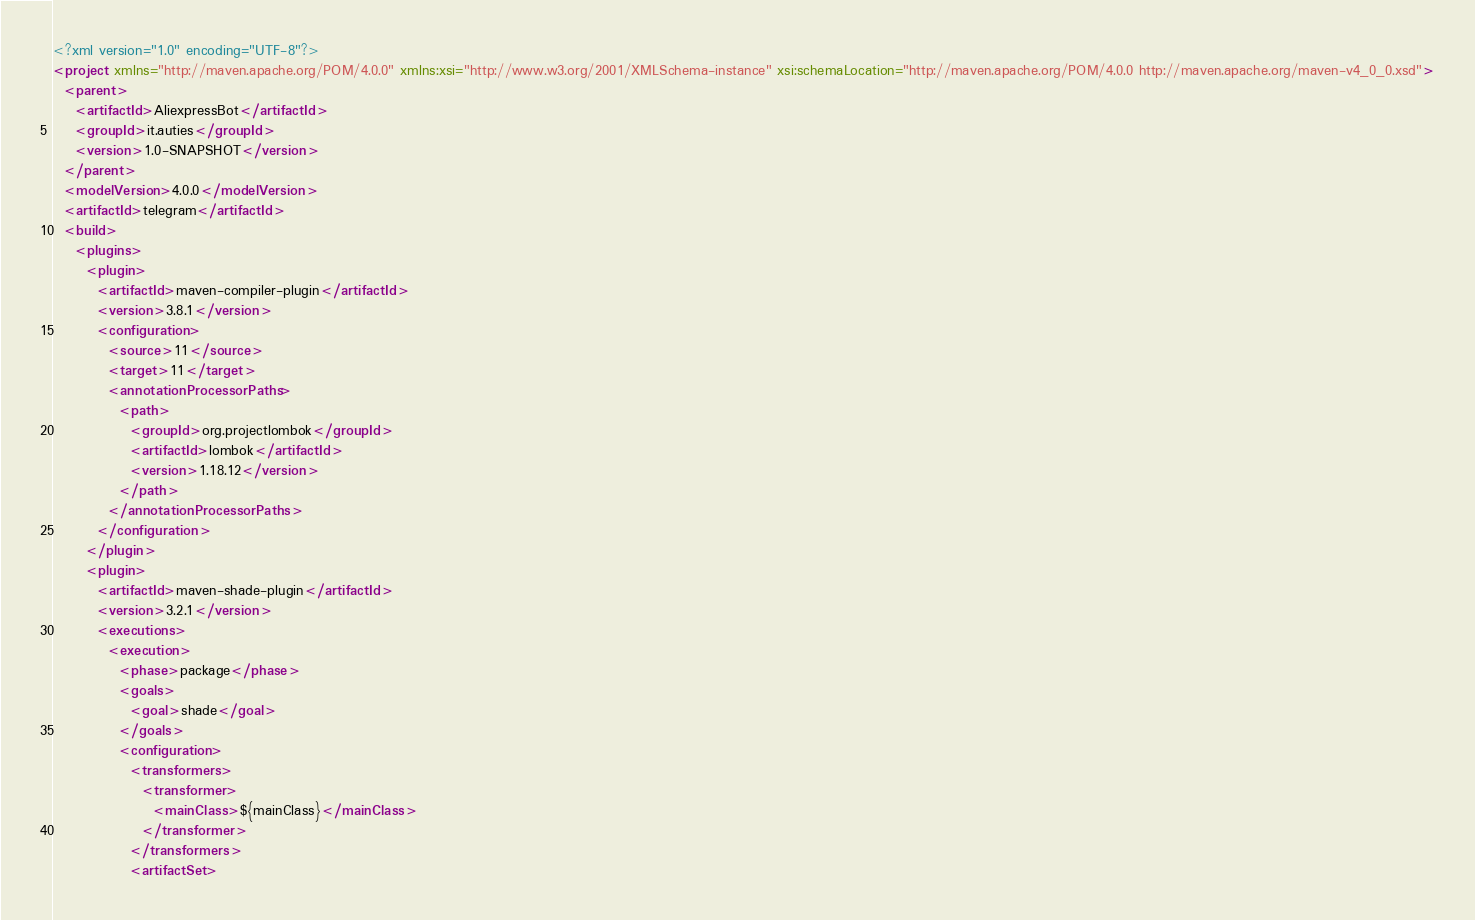Convert code to text. <code><loc_0><loc_0><loc_500><loc_500><_XML_><?xml version="1.0" encoding="UTF-8"?>
<project xmlns="http://maven.apache.org/POM/4.0.0" xmlns:xsi="http://www.w3.org/2001/XMLSchema-instance" xsi:schemaLocation="http://maven.apache.org/POM/4.0.0 http://maven.apache.org/maven-v4_0_0.xsd">
  <parent>
    <artifactId>AliexpressBot</artifactId>
    <groupId>it.auties</groupId>
    <version>1.0-SNAPSHOT</version>
  </parent>
  <modelVersion>4.0.0</modelVersion>
  <artifactId>telegram</artifactId>
  <build>
    <plugins>
      <plugin>
        <artifactId>maven-compiler-plugin</artifactId>
        <version>3.8.1</version>
        <configuration>
          <source>11</source>
          <target>11</target>
          <annotationProcessorPaths>
            <path>
              <groupId>org.projectlombok</groupId>
              <artifactId>lombok</artifactId>
              <version>1.18.12</version>
            </path>
          </annotationProcessorPaths>
        </configuration>
      </plugin>
      <plugin>
        <artifactId>maven-shade-plugin</artifactId>
        <version>3.2.1</version>
        <executions>
          <execution>
            <phase>package</phase>
            <goals>
              <goal>shade</goal>
            </goals>
            <configuration>
              <transformers>
                <transformer>
                  <mainClass>${mainClass}</mainClass>
                </transformer>
              </transformers>
              <artifactSet></code> 